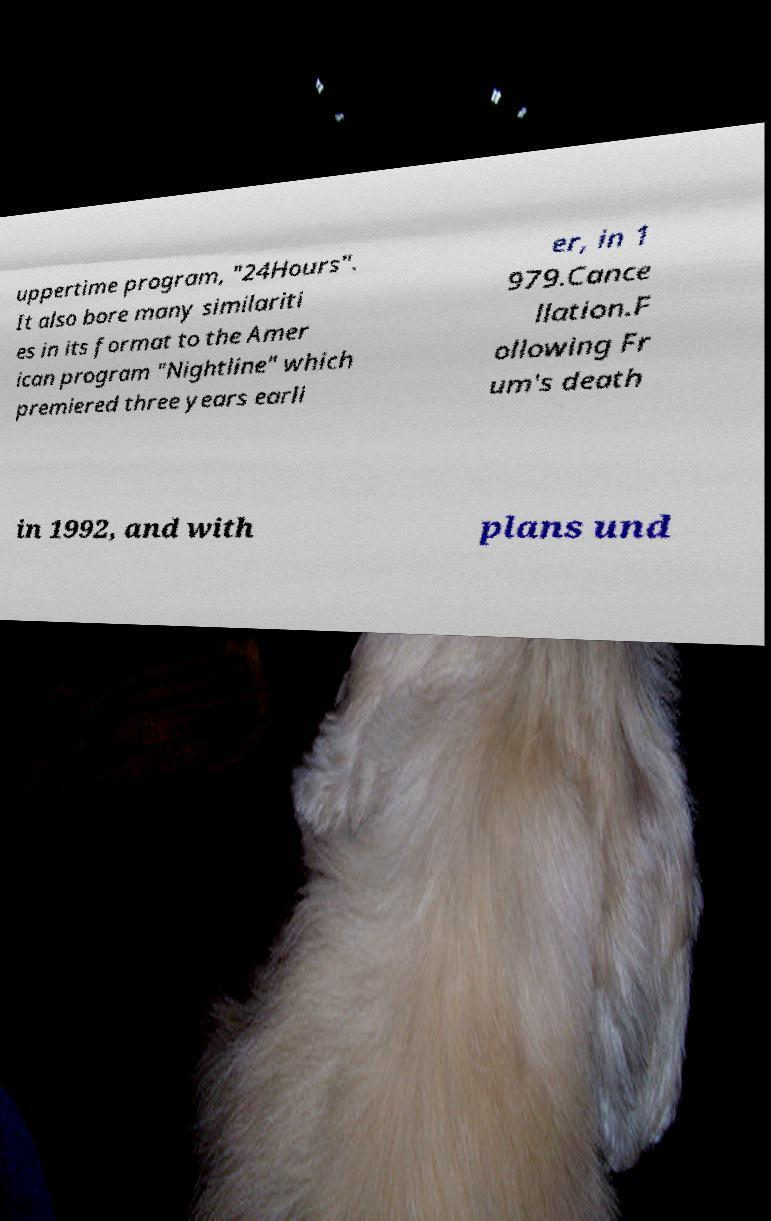What messages or text are displayed in this image? I need them in a readable, typed format. uppertime program, "24Hours". It also bore many similariti es in its format to the Amer ican program "Nightline" which premiered three years earli er, in 1 979.Cance llation.F ollowing Fr um's death in 1992, and with plans und 